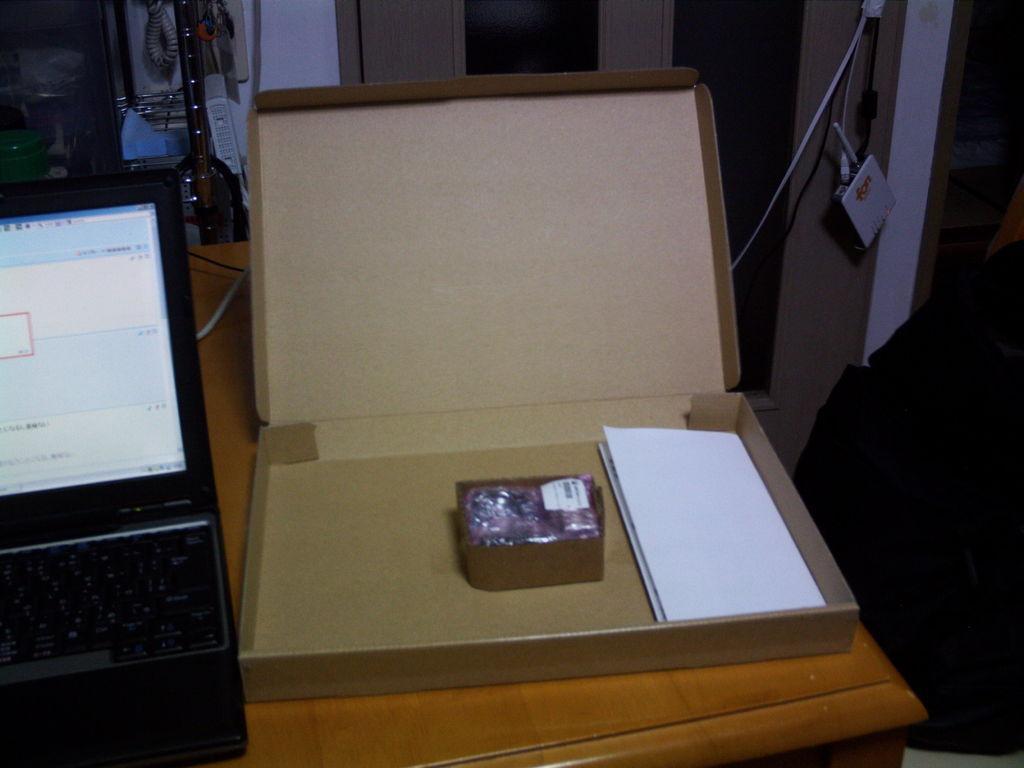How would you summarize this image in a sentence or two? In this image i can see a laptop, a cardboard, a paper on a table at the back ground i can see a pole and a wall. 